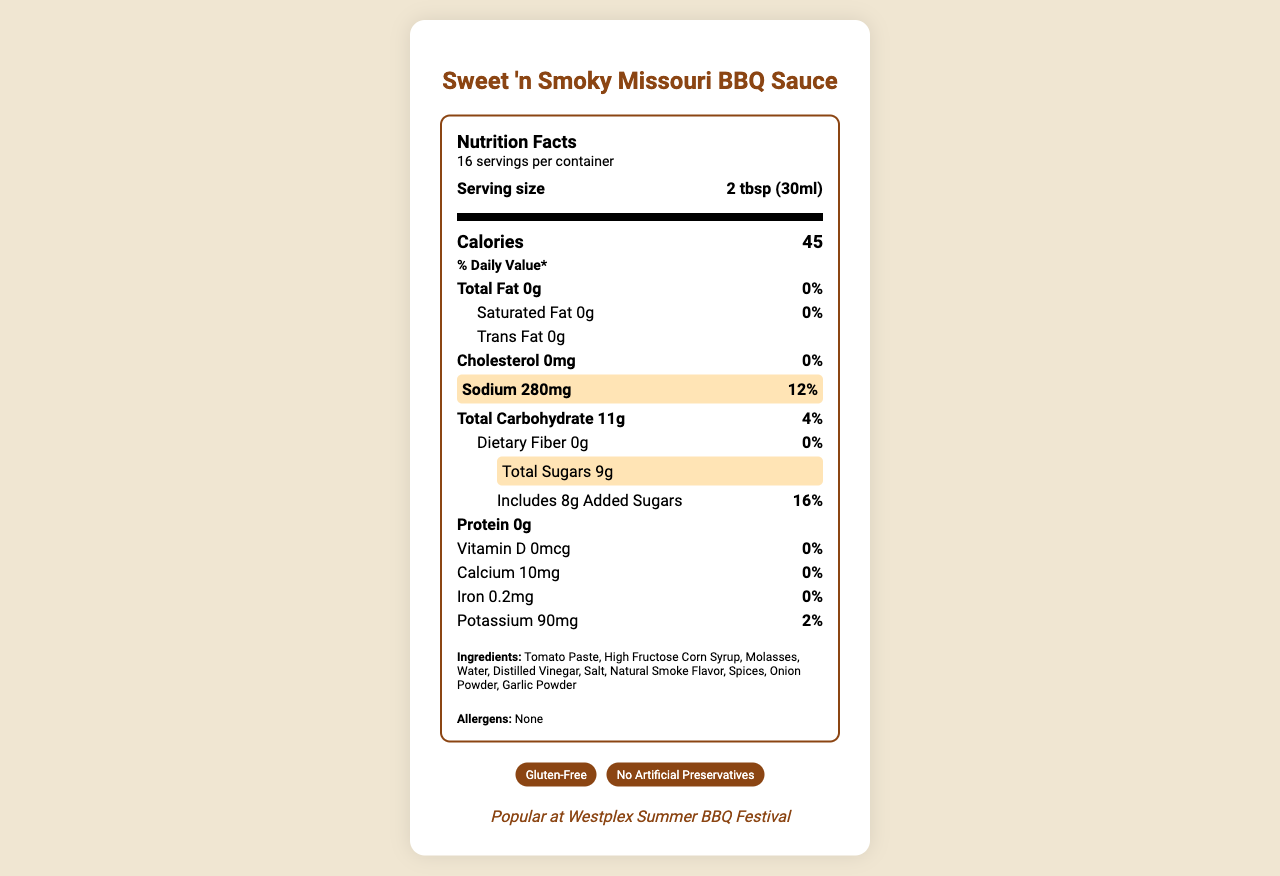what is the serving size of the Sweet 'n Smoky Missouri BBQ Sauce? The serving size is listed in the "Serving size" section at the top of the Nutrition Facts label.
Answer: 2 tbsp (30ml) what is the sodium content per serving? The sodium content per serving is highlighted in the "Sodium" row: 280 milligrams.
Answer: 280 mg how many grams of total sugars are there per serving? The total sugars per serving are displayed in the "Total Sugars" part of the Nutrition Facts label: 9 grams.
Answer: 9 grams what is the percentage daily value of sodium per serving? The sodium daily value percentage per serving is highlighted alongside the sodium milligrams, marked as 12%.
Answer: 12% what is the manufacturer address for the BBQ sauce? The manufacturer's address is located at the bottom of the document under manufacturerInfo: "123 Main Street, Westplex, MO 63366".
Answer: 123 Main Street, Westplex, MO 63366 how many servings are in one container? The number of servings per container is listed in the document: 16 servings per container.
Answer: 16 servings what is the main ingredient listed for the BBQ sauce? The first ingredient listed is often the main ingredient, so in this case, it is "Tomato Paste".
Answer: Tomato Paste which allergen is present in the BBQ sauce? The allergens section indicates that there are no allergens in the BBQ sauce.
Answer: None A person trying to minimize added sugars in their diet would like to know what percentage of daily value of added sugars they would consume with a single serving of this BBQ sauce. A. 8% B. 16% C. 20% D. 24% The daily value percentage of added sugars per serving is listed under total sugars and added sugars, which is 16%.
Answer: B If a person consumes 4 servings of this BBQ sauce, how many milligrams of sodium would they ingest? A. 560 mg B. 720 mg C. 1120 mg Consuming 4 servings would result in 280 mg per serving * 4 = 1120 mg of sodium.
Answer: C is this BBQ sauce gluten-free? The certifications section lists "Gluten-Free" indicating that the sauce is gluten-free.
Answer: Yes Summarize the key details of the Sweet 'n Smoky Missouri BBQ Sauce Nutrition Facts label. The label provides detailed nutritional information, including serving size, calorie count, various nutrient contents, and ingredients. It highlights the high sodium and sugar content per serving. The sauce also has several certifications and is popular at local events.
Answer: The Sweet 'n Smoky Missouri BBQ Sauce has a serving size of 2 tbsp (30ml) and provides 45 calories per serving. It contains 0g of fat, 280mg of sodium (12% daily value), 11g of carbohydrates, 9g of total sugars (including 8g of added sugars, 16% daily value), and 0g of protein. The ingredients include tomato paste, high fructose corn syrup, and molasses, among others. It is manufactured by Westplex Gourmet Foods in Missouri, is gluten-free, and contains no allergens. What is the average amount of added sugars in BBQ sauces produced by Westplex Gourmet Foods? The document only provides the added sugar content for the Sweet 'n Smoky Missouri BBQ Sauce and does not include information about other BBQ sauces produced by the manufacturer.
Answer: Cannot be determined 